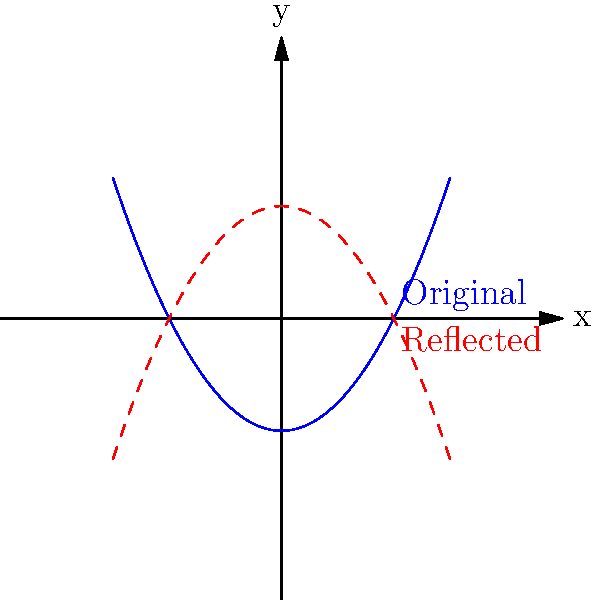In a stress test for climbing equipment, the results are plotted on a coordinate plane. The blue curve represents the original data, and the red dashed curve is a reflection of the blue curve. What type of symmetry exists between these two curves, and about which axis or point is this symmetry? To determine the symmetry between the two curves, we need to analyze their relationship:

1. Observe that the red dashed curve appears to be an upside-down version of the blue curve.

2. The equation for the blue curve can be represented as $y = f(x)$, where $f(x) = 0.5x^2 - 2$ (a parabola).

3. The equation for the red dashed curve would be $y = -f(x)$, which is the negative of the original function.

4. When we negate a function, it reflects over the x-axis. This means that for every point $(x, y)$ on the blue curve, there is a corresponding point $(x, -y)$ on the red curve.

5. The line of symmetry between these two curves is the x-axis (y = 0).

6. This type of symmetry, where one shape is the mirror image of another across a line, is called line symmetry or reflection symmetry.

Therefore, the two curves exhibit line symmetry (reflection symmetry) about the x-axis.
Answer: Line symmetry about the x-axis 